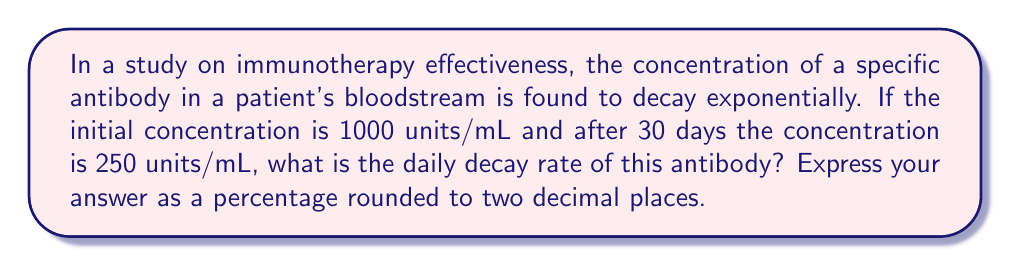Help me with this question. To solve this problem, we'll use the exponential decay formula:

$$A(t) = A_0 \cdot (1-r)^t$$

Where:
$A(t)$ is the amount at time $t$
$A_0$ is the initial amount
$r$ is the daily decay rate
$t$ is the time in days

We know:
$A_0 = 1000$ units/mL
$A(30) = 250$ units/mL
$t = 30$ days

Let's plug these values into the formula:

$$250 = 1000 \cdot (1-r)^{30}$$

Dividing both sides by 1000:

$$0.25 = (1-r)^{30}$$

Taking the 30th root of both sides:

$$\sqrt[30]{0.25} = 1-r$$

$$\sqrt[30]{0.25} \approx 0.9550$$

Now we can solve for $r$:

$$1 - 0.9550 = r$$
$$0.0450 = r$$

To express this as a percentage, we multiply by 100:

$$0.0450 \times 100 = 4.50\%$$

Therefore, the daily decay rate is approximately 4.50%.
Answer: 4.50% 